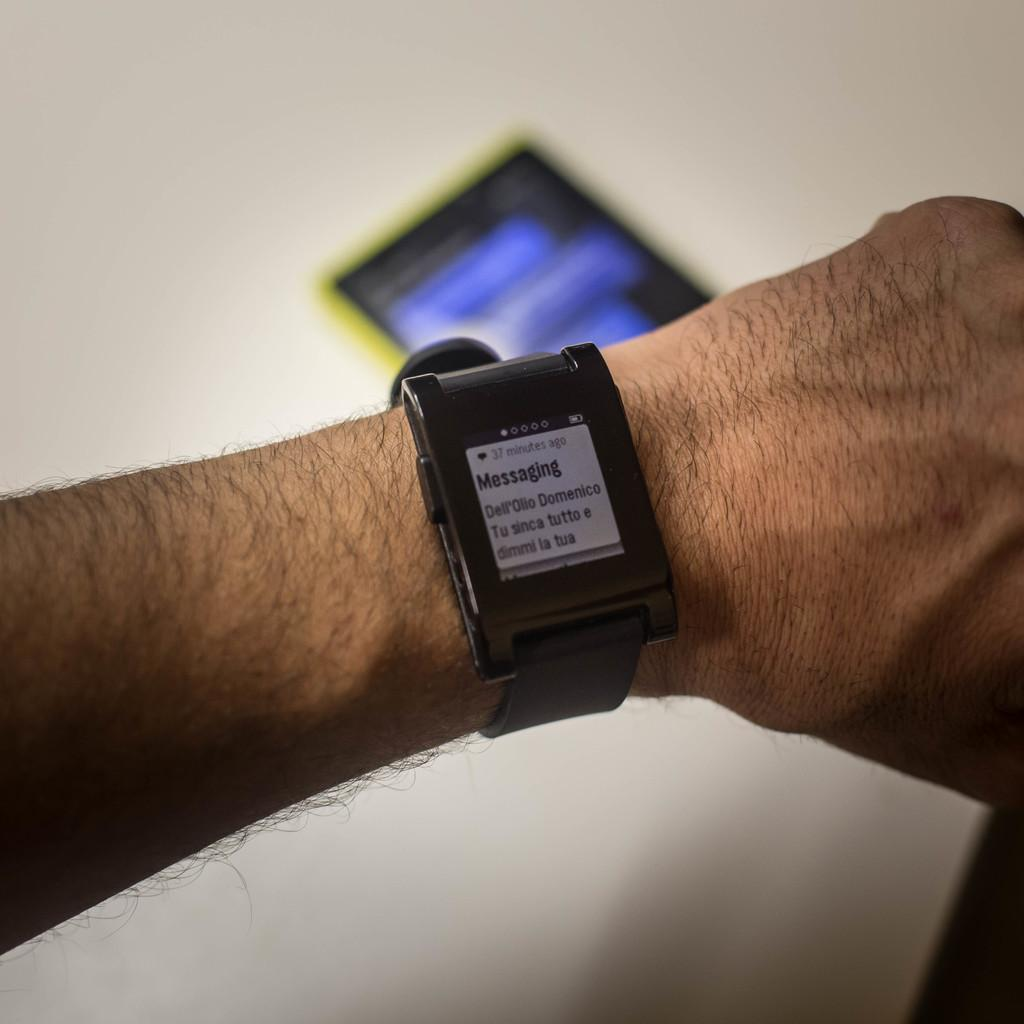Provide a one-sentence caption for the provided image. A smart watch on a wrist displaying a message. 